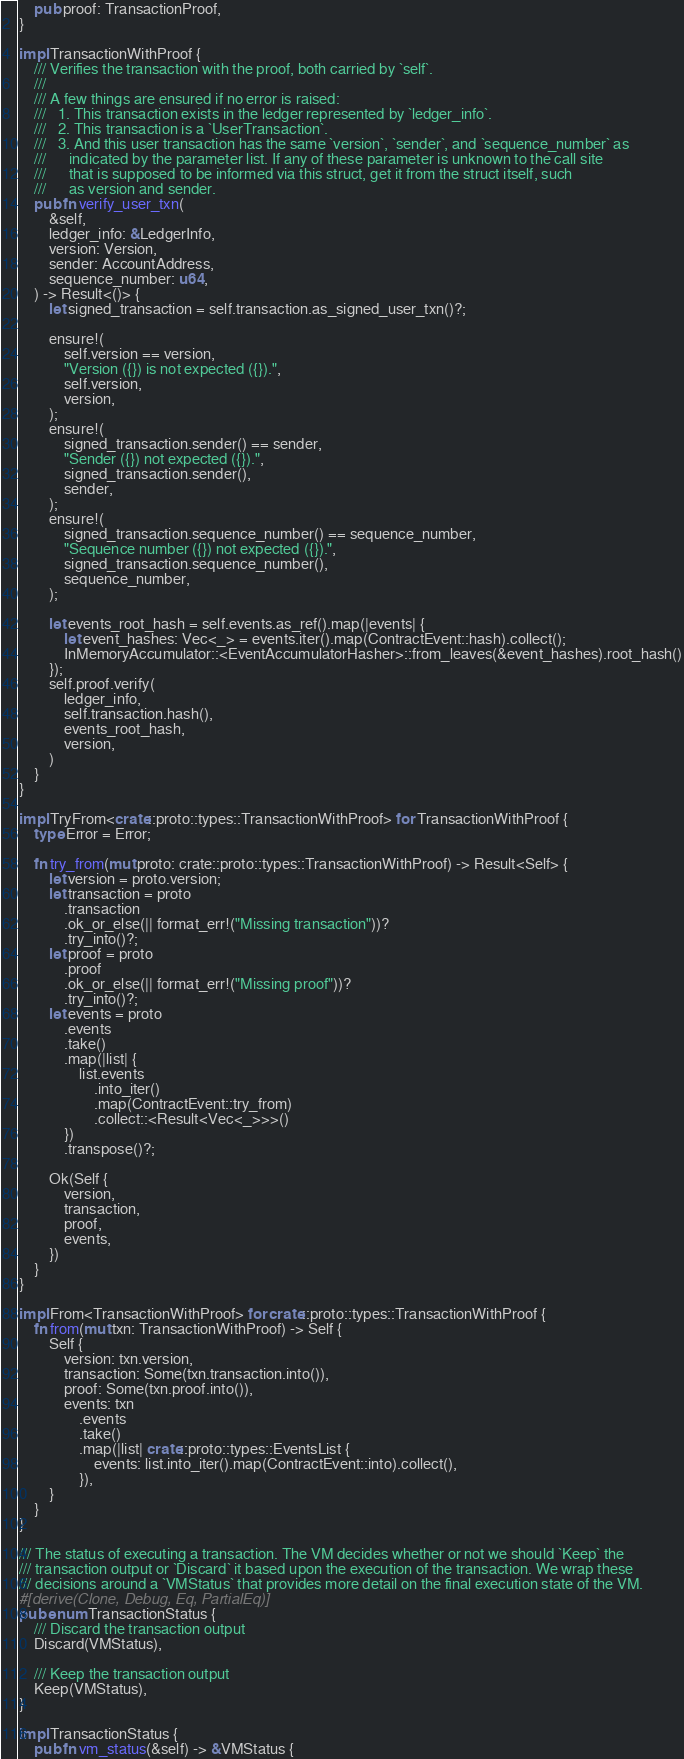Convert code to text. <code><loc_0><loc_0><loc_500><loc_500><_Rust_>    pub proof: TransactionProof,
}

impl TransactionWithProof {
    /// Verifies the transaction with the proof, both carried by `self`.
    ///
    /// A few things are ensured if no error is raised:
    ///   1. This transaction exists in the ledger represented by `ledger_info`.
    ///   2. This transaction is a `UserTransaction`.
    ///   3. And this user transaction has the same `version`, `sender`, and `sequence_number` as
    ///      indicated by the parameter list. If any of these parameter is unknown to the call site
    ///      that is supposed to be informed via this struct, get it from the struct itself, such
    ///      as version and sender.
    pub fn verify_user_txn(
        &self,
        ledger_info: &LedgerInfo,
        version: Version,
        sender: AccountAddress,
        sequence_number: u64,
    ) -> Result<()> {
        let signed_transaction = self.transaction.as_signed_user_txn()?;

        ensure!(
            self.version == version,
            "Version ({}) is not expected ({}).",
            self.version,
            version,
        );
        ensure!(
            signed_transaction.sender() == sender,
            "Sender ({}) not expected ({}).",
            signed_transaction.sender(),
            sender,
        );
        ensure!(
            signed_transaction.sequence_number() == sequence_number,
            "Sequence number ({}) not expected ({}).",
            signed_transaction.sequence_number(),
            sequence_number,
        );

        let events_root_hash = self.events.as_ref().map(|events| {
            let event_hashes: Vec<_> = events.iter().map(ContractEvent::hash).collect();
            InMemoryAccumulator::<EventAccumulatorHasher>::from_leaves(&event_hashes).root_hash()
        });
        self.proof.verify(
            ledger_info,
            self.transaction.hash(),
            events_root_hash,
            version,
        )
    }
}

impl TryFrom<crate::proto::types::TransactionWithProof> for TransactionWithProof {
    type Error = Error;

    fn try_from(mut proto: crate::proto::types::TransactionWithProof) -> Result<Self> {
        let version = proto.version;
        let transaction = proto
            .transaction
            .ok_or_else(|| format_err!("Missing transaction"))?
            .try_into()?;
        let proof = proto
            .proof
            .ok_or_else(|| format_err!("Missing proof"))?
            .try_into()?;
        let events = proto
            .events
            .take()
            .map(|list| {
                list.events
                    .into_iter()
                    .map(ContractEvent::try_from)
                    .collect::<Result<Vec<_>>>()
            })
            .transpose()?;

        Ok(Self {
            version,
            transaction,
            proof,
            events,
        })
    }
}

impl From<TransactionWithProof> for crate::proto::types::TransactionWithProof {
    fn from(mut txn: TransactionWithProof) -> Self {
        Self {
            version: txn.version,
            transaction: Some(txn.transaction.into()),
            proof: Some(txn.proof.into()),
            events: txn
                .events
                .take()
                .map(|list| crate::proto::types::EventsList {
                    events: list.into_iter().map(ContractEvent::into).collect(),
                }),
        }
    }
}

/// The status of executing a transaction. The VM decides whether or not we should `Keep` the
/// transaction output or `Discard` it based upon the execution of the transaction. We wrap these
/// decisions around a `VMStatus` that provides more detail on the final execution state of the VM.
#[derive(Clone, Debug, Eq, PartialEq)]
pub enum TransactionStatus {
    /// Discard the transaction output
    Discard(VMStatus),

    /// Keep the transaction output
    Keep(VMStatus),
}

impl TransactionStatus {
    pub fn vm_status(&self) -> &VMStatus {</code> 